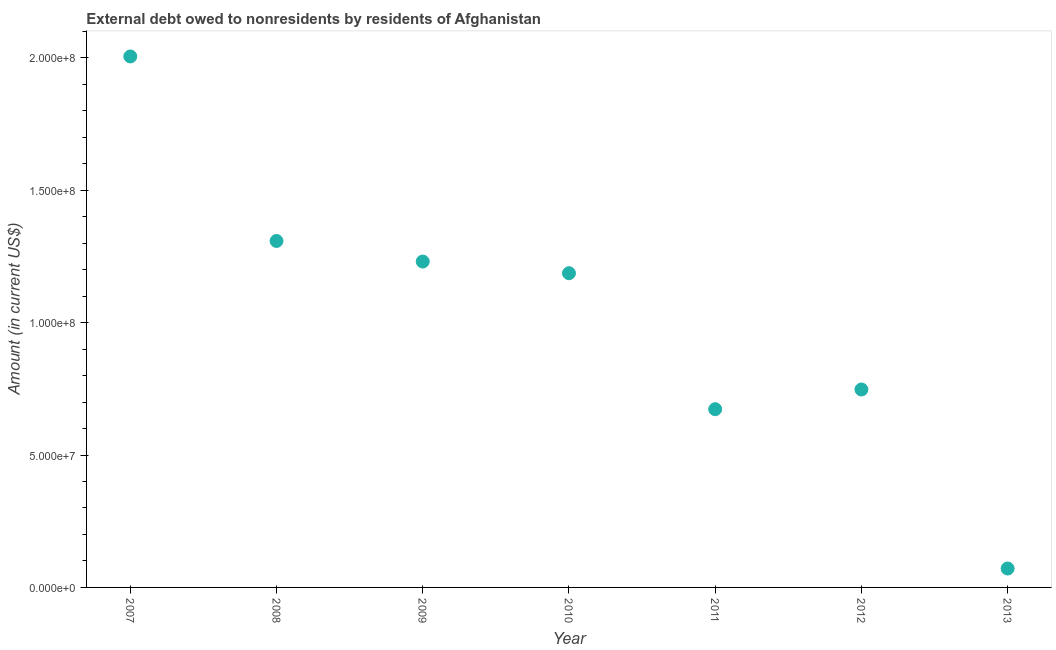What is the debt in 2010?
Give a very brief answer. 1.19e+08. Across all years, what is the maximum debt?
Ensure brevity in your answer.  2.01e+08. Across all years, what is the minimum debt?
Offer a very short reply. 7.14e+06. In which year was the debt maximum?
Keep it short and to the point. 2007. What is the sum of the debt?
Your answer should be compact. 7.22e+08. What is the difference between the debt in 2009 and 2012?
Provide a succinct answer. 4.83e+07. What is the average debt per year?
Give a very brief answer. 1.03e+08. What is the median debt?
Keep it short and to the point. 1.19e+08. In how many years, is the debt greater than 160000000 US$?
Your response must be concise. 1. Do a majority of the years between 2013 and 2009 (inclusive) have debt greater than 100000000 US$?
Your answer should be compact. Yes. What is the ratio of the debt in 2008 to that in 2013?
Provide a succinct answer. 18.33. Is the debt in 2008 less than that in 2011?
Your answer should be compact. No. What is the difference between the highest and the second highest debt?
Ensure brevity in your answer.  6.97e+07. What is the difference between the highest and the lowest debt?
Your answer should be very brief. 1.93e+08. In how many years, is the debt greater than the average debt taken over all years?
Provide a succinct answer. 4. Does the debt monotonically increase over the years?
Provide a short and direct response. No. What is the difference between two consecutive major ticks on the Y-axis?
Offer a very short reply. 5.00e+07. Does the graph contain any zero values?
Keep it short and to the point. No. What is the title of the graph?
Provide a short and direct response. External debt owed to nonresidents by residents of Afghanistan. What is the label or title of the Y-axis?
Your response must be concise. Amount (in current US$). What is the Amount (in current US$) in 2007?
Your response must be concise. 2.01e+08. What is the Amount (in current US$) in 2008?
Provide a succinct answer. 1.31e+08. What is the Amount (in current US$) in 2009?
Ensure brevity in your answer.  1.23e+08. What is the Amount (in current US$) in 2010?
Provide a short and direct response. 1.19e+08. What is the Amount (in current US$) in 2011?
Make the answer very short. 6.73e+07. What is the Amount (in current US$) in 2012?
Your response must be concise. 7.48e+07. What is the Amount (in current US$) in 2013?
Your answer should be very brief. 7.14e+06. What is the difference between the Amount (in current US$) in 2007 and 2008?
Make the answer very short. 6.97e+07. What is the difference between the Amount (in current US$) in 2007 and 2009?
Offer a terse response. 7.75e+07. What is the difference between the Amount (in current US$) in 2007 and 2010?
Ensure brevity in your answer.  8.19e+07. What is the difference between the Amount (in current US$) in 2007 and 2011?
Ensure brevity in your answer.  1.33e+08. What is the difference between the Amount (in current US$) in 2007 and 2012?
Provide a succinct answer. 1.26e+08. What is the difference between the Amount (in current US$) in 2007 and 2013?
Ensure brevity in your answer.  1.93e+08. What is the difference between the Amount (in current US$) in 2008 and 2009?
Provide a short and direct response. 7.76e+06. What is the difference between the Amount (in current US$) in 2008 and 2010?
Keep it short and to the point. 1.22e+07. What is the difference between the Amount (in current US$) in 2008 and 2011?
Offer a terse response. 6.35e+07. What is the difference between the Amount (in current US$) in 2008 and 2012?
Your answer should be compact. 5.61e+07. What is the difference between the Amount (in current US$) in 2008 and 2013?
Provide a short and direct response. 1.24e+08. What is the difference between the Amount (in current US$) in 2009 and 2010?
Your answer should be compact. 4.41e+06. What is the difference between the Amount (in current US$) in 2009 and 2011?
Your answer should be compact. 5.58e+07. What is the difference between the Amount (in current US$) in 2009 and 2012?
Offer a very short reply. 4.83e+07. What is the difference between the Amount (in current US$) in 2009 and 2013?
Give a very brief answer. 1.16e+08. What is the difference between the Amount (in current US$) in 2010 and 2011?
Keep it short and to the point. 5.14e+07. What is the difference between the Amount (in current US$) in 2010 and 2012?
Provide a short and direct response. 4.39e+07. What is the difference between the Amount (in current US$) in 2010 and 2013?
Give a very brief answer. 1.12e+08. What is the difference between the Amount (in current US$) in 2011 and 2012?
Offer a terse response. -7.45e+06. What is the difference between the Amount (in current US$) in 2011 and 2013?
Your response must be concise. 6.02e+07. What is the difference between the Amount (in current US$) in 2012 and 2013?
Offer a terse response. 6.76e+07. What is the ratio of the Amount (in current US$) in 2007 to that in 2008?
Your answer should be very brief. 1.53. What is the ratio of the Amount (in current US$) in 2007 to that in 2009?
Offer a very short reply. 1.63. What is the ratio of the Amount (in current US$) in 2007 to that in 2010?
Give a very brief answer. 1.69. What is the ratio of the Amount (in current US$) in 2007 to that in 2011?
Your answer should be compact. 2.98. What is the ratio of the Amount (in current US$) in 2007 to that in 2012?
Provide a short and direct response. 2.68. What is the ratio of the Amount (in current US$) in 2007 to that in 2013?
Provide a succinct answer. 28.09. What is the ratio of the Amount (in current US$) in 2008 to that in 2009?
Give a very brief answer. 1.06. What is the ratio of the Amount (in current US$) in 2008 to that in 2010?
Offer a terse response. 1.1. What is the ratio of the Amount (in current US$) in 2008 to that in 2011?
Offer a terse response. 1.94. What is the ratio of the Amount (in current US$) in 2008 to that in 2013?
Provide a succinct answer. 18.33. What is the ratio of the Amount (in current US$) in 2009 to that in 2010?
Your answer should be compact. 1.04. What is the ratio of the Amount (in current US$) in 2009 to that in 2011?
Give a very brief answer. 1.83. What is the ratio of the Amount (in current US$) in 2009 to that in 2012?
Keep it short and to the point. 1.65. What is the ratio of the Amount (in current US$) in 2009 to that in 2013?
Your answer should be very brief. 17.24. What is the ratio of the Amount (in current US$) in 2010 to that in 2011?
Offer a terse response. 1.76. What is the ratio of the Amount (in current US$) in 2010 to that in 2012?
Offer a terse response. 1.59. What is the ratio of the Amount (in current US$) in 2010 to that in 2013?
Keep it short and to the point. 16.62. What is the ratio of the Amount (in current US$) in 2011 to that in 2012?
Keep it short and to the point. 0.9. What is the ratio of the Amount (in current US$) in 2011 to that in 2013?
Provide a succinct answer. 9.43. What is the ratio of the Amount (in current US$) in 2012 to that in 2013?
Your answer should be very brief. 10.47. 